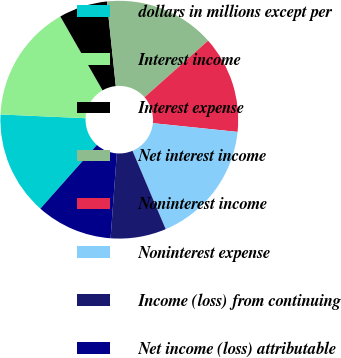<chart> <loc_0><loc_0><loc_500><loc_500><pie_chart><fcel>dollars in millions except per<fcel>Interest income<fcel>Interest expense<fcel>Net interest income<fcel>Noninterest income<fcel>Noninterest expense<fcel>Income (loss) from continuing<fcel>Net income (loss) attributable<nl><fcel>14.15%<fcel>16.04%<fcel>6.6%<fcel>15.09%<fcel>13.21%<fcel>16.98%<fcel>7.55%<fcel>10.38%<nl></chart> 